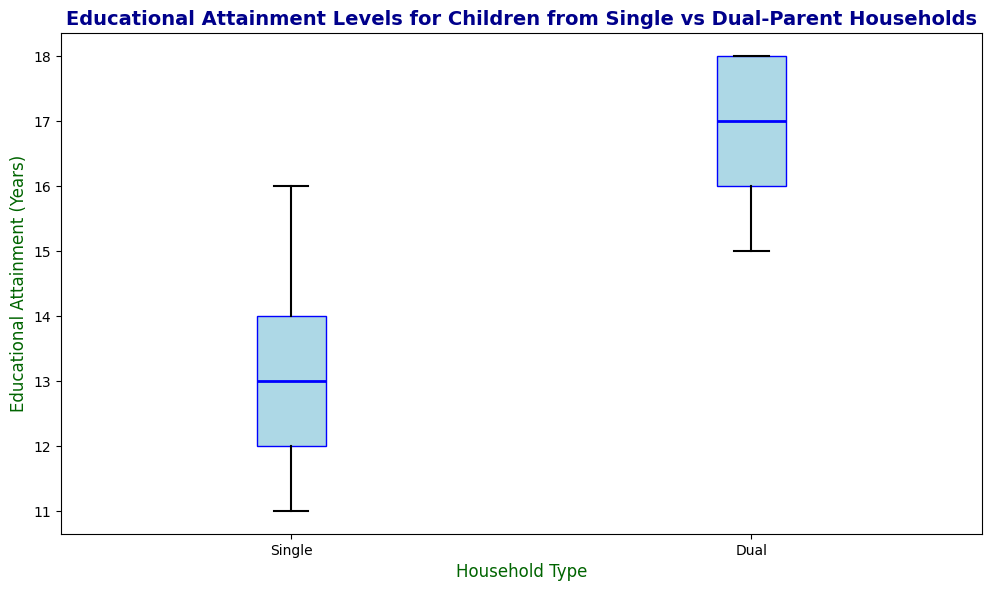What's the median educational attainment for children from single-parent households? To find the median, observe the middle value of the data points for single-parent households. The middle value falls halfway when the data points are ordered from the smallest to the largest.
Answer: 13 Which household type has a higher median educational attainment? Compare the median values of both single and dual-parent households. The box plots will show that the median line (inside the box) for dual-parent households is higher than for single-parent households.
Answer: Dual-parent households What is the interquartile range (IQR) for dual-parent households? The IQR is calculated as the difference between the third quartile (Q3) and the first quartile (Q1). In the box plot, Q3 is the top edge of the box, and Q1 is the bottom edge. For dual-parent households, Q3 is 18 and Q1 is 16.
Answer: 2 Which group has a wider range of educational attainment? The range is determined as the difference between the maximum and minimum values. Single-parent households have a minimum of 11 and a maximum of 16, making their range \(16 - 11 = 5\). Dual-parent households have a minimum of 15 and a maximum of 18, resulting in a range of \(18 - 15 = 3\).
Answer: Single-parent households Are there any outliers in the data, and if so, which household type has them? Outliers are indicated by individual points outside the whiskers of the box plot. For both single and dual-parent households, check if any points lie beyond the main range of the box plot whiskers. In this case, there are no outliers.
Answer: No outliers Which household type has greater variability in educational attainment levels? The variability or spread of the data can be inferred from the length of the boxes and the whiskers. The measure to consider is the IQR, as a larger IQR indicates greater variability. The single-parent households show a larger box (IQR) compared to dual-parent households.
Answer: Single-parent households What is the median educational attainment for dual-parent households? Observe the median line inside the box plot for dual-parent households, which corresponds to the middle value when data points are listed in ascending order.
Answer: 17 